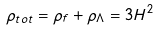Convert formula to latex. <formula><loc_0><loc_0><loc_500><loc_500>\rho _ { t o t } = \rho _ { f } + \rho _ { \Lambda } = 3 H ^ { 2 }</formula> 